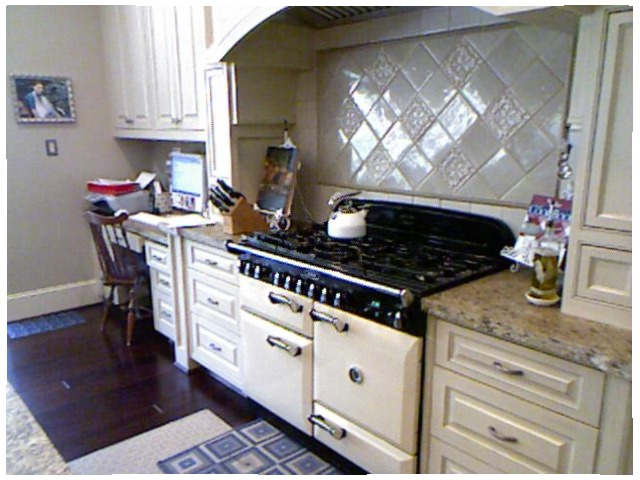<image>
Can you confirm if the kettle is on the gas stove? Yes. Looking at the image, I can see the kettle is positioned on top of the gas stove, with the gas stove providing support. Is there a stove on the rug? No. The stove is not positioned on the rug. They may be near each other, but the stove is not supported by or resting on top of the rug. Where is the kettle in relation to the drawer? Is it in the drawer? No. The kettle is not contained within the drawer. These objects have a different spatial relationship. 